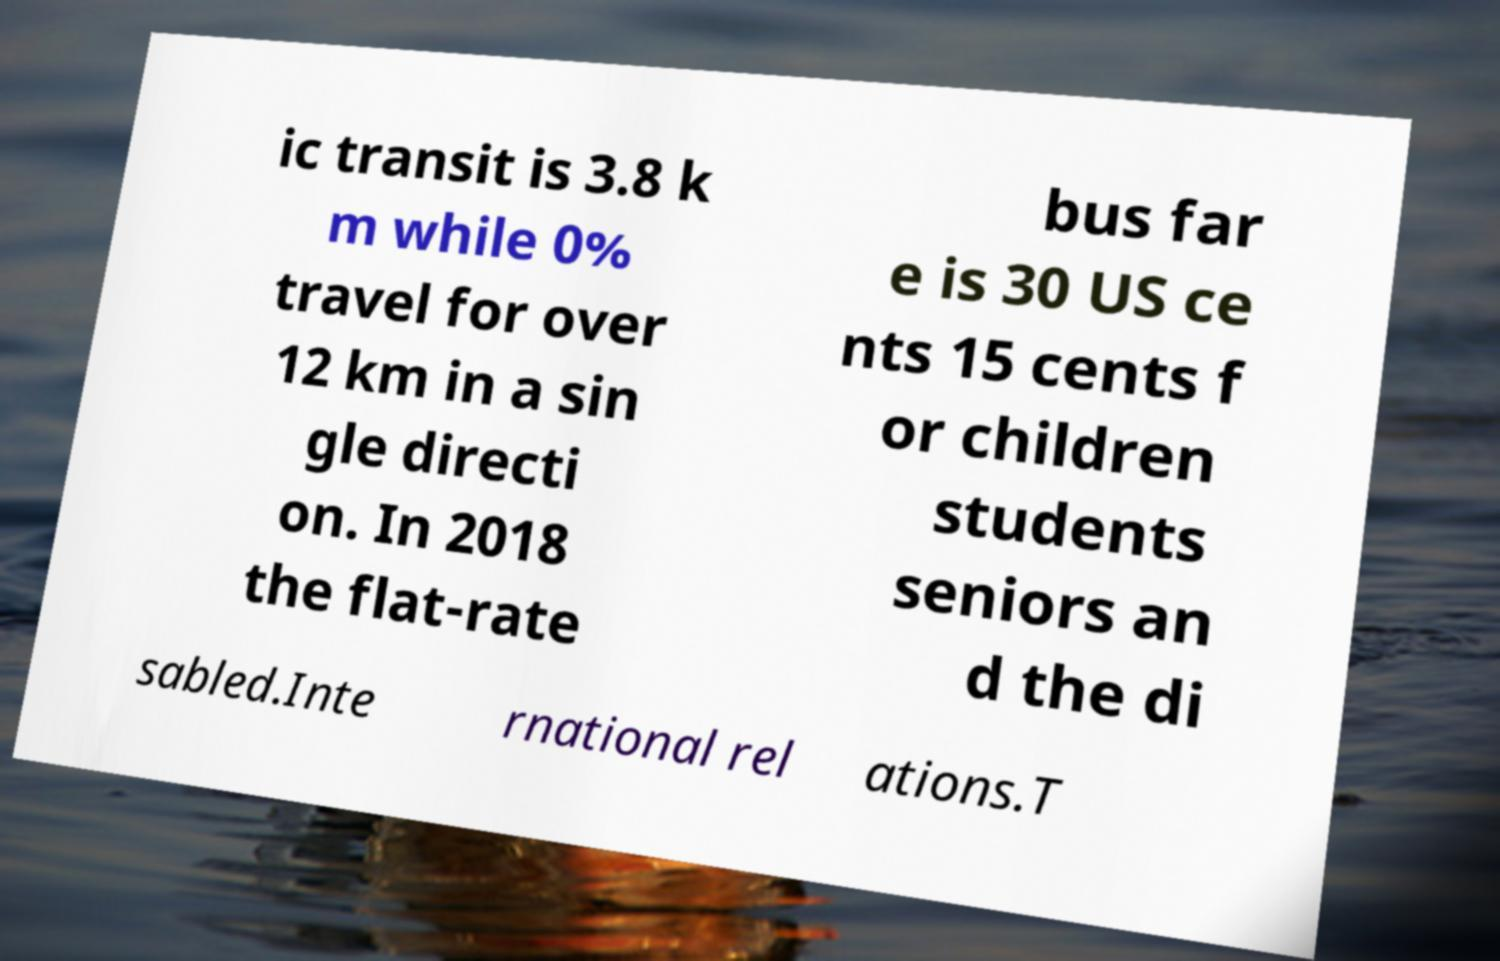Please read and relay the text visible in this image. What does it say? ic transit is 3.8 k m while 0% travel for over 12 km in a sin gle directi on. In 2018 the flat-rate bus far e is 30 US ce nts 15 cents f or children students seniors an d the di sabled.Inte rnational rel ations.T 